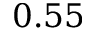<formula> <loc_0><loc_0><loc_500><loc_500>0 . 5 5</formula> 